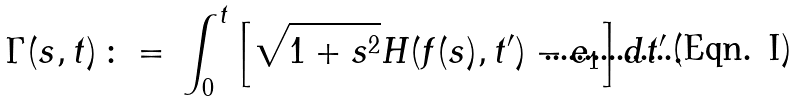<formula> <loc_0><loc_0><loc_500><loc_500>\Gamma ( s , t ) \, \colon = \, \int _ { 0 } ^ { t } \left [ \sqrt { 1 + s ^ { 2 } } H ( f ( s ) , t ^ { \prime } ) - e _ { 1 } \right ] d t ^ { \prime } \, .</formula> 